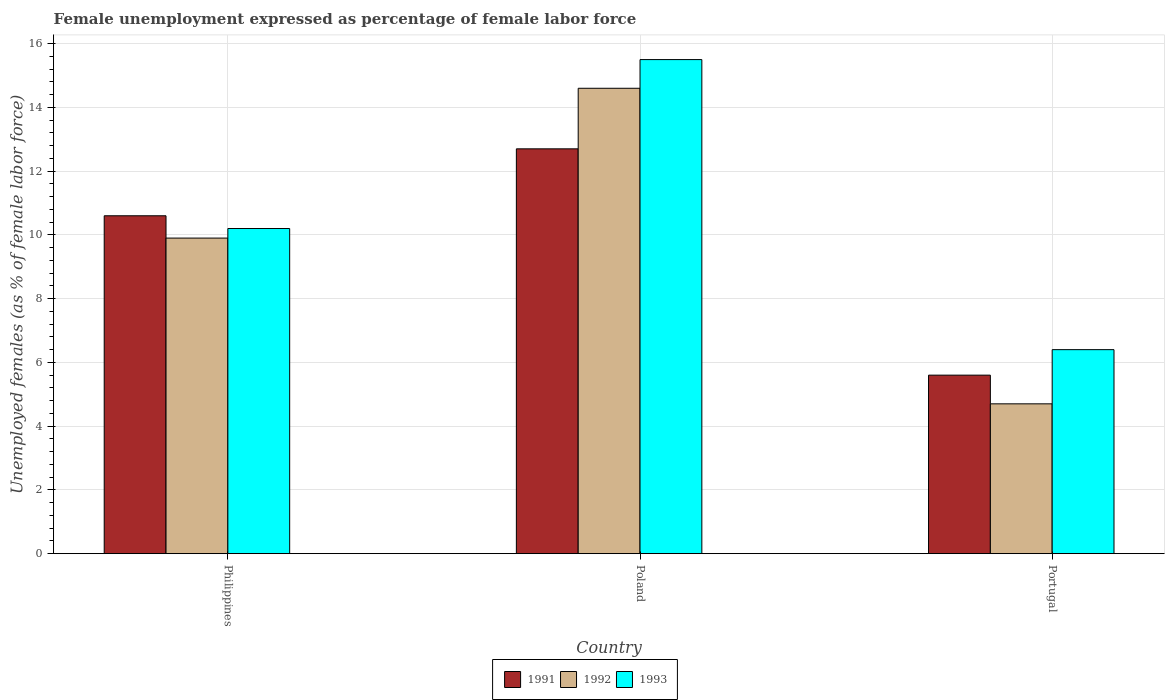How many different coloured bars are there?
Provide a short and direct response. 3. How many groups of bars are there?
Give a very brief answer. 3. What is the label of the 2nd group of bars from the left?
Your response must be concise. Poland. In how many cases, is the number of bars for a given country not equal to the number of legend labels?
Give a very brief answer. 0. What is the unemployment in females in in 1993 in Philippines?
Ensure brevity in your answer.  10.2. Across all countries, what is the maximum unemployment in females in in 1991?
Your response must be concise. 12.7. Across all countries, what is the minimum unemployment in females in in 1992?
Your answer should be compact. 4.7. In which country was the unemployment in females in in 1991 maximum?
Provide a short and direct response. Poland. In which country was the unemployment in females in in 1991 minimum?
Your response must be concise. Portugal. What is the total unemployment in females in in 1993 in the graph?
Offer a very short reply. 32.1. What is the difference between the unemployment in females in in 1993 in Philippines and that in Poland?
Make the answer very short. -5.3. What is the difference between the unemployment in females in in 1992 in Poland and the unemployment in females in in 1991 in Philippines?
Your response must be concise. 4. What is the average unemployment in females in in 1991 per country?
Make the answer very short. 9.63. What is the difference between the unemployment in females in of/in 1992 and unemployment in females in of/in 1991 in Portugal?
Your answer should be very brief. -0.9. What is the ratio of the unemployment in females in in 1991 in Philippines to that in Poland?
Give a very brief answer. 0.83. Is the unemployment in females in in 1992 in Poland less than that in Portugal?
Your response must be concise. No. Is the difference between the unemployment in females in in 1992 in Philippines and Portugal greater than the difference between the unemployment in females in in 1991 in Philippines and Portugal?
Provide a short and direct response. Yes. What is the difference between the highest and the second highest unemployment in females in in 1992?
Your response must be concise. 5.2. What is the difference between the highest and the lowest unemployment in females in in 1993?
Make the answer very short. 9.1. In how many countries, is the unemployment in females in in 1993 greater than the average unemployment in females in in 1993 taken over all countries?
Your answer should be very brief. 1. Is the sum of the unemployment in females in in 1991 in Philippines and Portugal greater than the maximum unemployment in females in in 1993 across all countries?
Ensure brevity in your answer.  Yes. What does the 3rd bar from the right in Philippines represents?
Make the answer very short. 1991. Is it the case that in every country, the sum of the unemployment in females in in 1992 and unemployment in females in in 1993 is greater than the unemployment in females in in 1991?
Your answer should be compact. Yes. Are all the bars in the graph horizontal?
Keep it short and to the point. No. Are the values on the major ticks of Y-axis written in scientific E-notation?
Your answer should be very brief. No. Does the graph contain any zero values?
Your response must be concise. No. Does the graph contain grids?
Your response must be concise. Yes. How are the legend labels stacked?
Your answer should be very brief. Horizontal. What is the title of the graph?
Your answer should be compact. Female unemployment expressed as percentage of female labor force. Does "2013" appear as one of the legend labels in the graph?
Your response must be concise. No. What is the label or title of the X-axis?
Make the answer very short. Country. What is the label or title of the Y-axis?
Your answer should be very brief. Unemployed females (as % of female labor force). What is the Unemployed females (as % of female labor force) of 1991 in Philippines?
Ensure brevity in your answer.  10.6. What is the Unemployed females (as % of female labor force) in 1992 in Philippines?
Provide a short and direct response. 9.9. What is the Unemployed females (as % of female labor force) of 1993 in Philippines?
Provide a short and direct response. 10.2. What is the Unemployed females (as % of female labor force) in 1991 in Poland?
Offer a very short reply. 12.7. What is the Unemployed females (as % of female labor force) in 1992 in Poland?
Give a very brief answer. 14.6. What is the Unemployed females (as % of female labor force) in 1993 in Poland?
Offer a very short reply. 15.5. What is the Unemployed females (as % of female labor force) of 1991 in Portugal?
Offer a very short reply. 5.6. What is the Unemployed females (as % of female labor force) of 1992 in Portugal?
Ensure brevity in your answer.  4.7. What is the Unemployed females (as % of female labor force) in 1993 in Portugal?
Offer a very short reply. 6.4. Across all countries, what is the maximum Unemployed females (as % of female labor force) of 1991?
Your answer should be compact. 12.7. Across all countries, what is the maximum Unemployed females (as % of female labor force) in 1992?
Your response must be concise. 14.6. Across all countries, what is the maximum Unemployed females (as % of female labor force) of 1993?
Provide a short and direct response. 15.5. Across all countries, what is the minimum Unemployed females (as % of female labor force) in 1991?
Give a very brief answer. 5.6. Across all countries, what is the minimum Unemployed females (as % of female labor force) of 1992?
Your answer should be very brief. 4.7. Across all countries, what is the minimum Unemployed females (as % of female labor force) in 1993?
Provide a succinct answer. 6.4. What is the total Unemployed females (as % of female labor force) in 1991 in the graph?
Offer a very short reply. 28.9. What is the total Unemployed females (as % of female labor force) in 1992 in the graph?
Your answer should be very brief. 29.2. What is the total Unemployed females (as % of female labor force) of 1993 in the graph?
Provide a short and direct response. 32.1. What is the difference between the Unemployed females (as % of female labor force) of 1991 in Philippines and that in Poland?
Make the answer very short. -2.1. What is the difference between the Unemployed females (as % of female labor force) of 1991 in Philippines and that in Portugal?
Your answer should be compact. 5. What is the difference between the Unemployed females (as % of female labor force) of 1992 in Philippines and that in Portugal?
Keep it short and to the point. 5.2. What is the difference between the Unemployed females (as % of female labor force) of 1991 in Poland and that in Portugal?
Your answer should be very brief. 7.1. What is the difference between the Unemployed females (as % of female labor force) of 1993 in Poland and that in Portugal?
Keep it short and to the point. 9.1. What is the difference between the Unemployed females (as % of female labor force) in 1991 in Philippines and the Unemployed females (as % of female labor force) in 1992 in Poland?
Offer a terse response. -4. What is the difference between the Unemployed females (as % of female labor force) of 1991 in Philippines and the Unemployed females (as % of female labor force) of 1993 in Poland?
Give a very brief answer. -4.9. What is the difference between the Unemployed females (as % of female labor force) in 1992 in Philippines and the Unemployed females (as % of female labor force) in 1993 in Poland?
Provide a short and direct response. -5.6. What is the difference between the Unemployed females (as % of female labor force) in 1991 in Philippines and the Unemployed females (as % of female labor force) in 1992 in Portugal?
Your answer should be compact. 5.9. What is the difference between the Unemployed females (as % of female labor force) in 1992 in Philippines and the Unemployed females (as % of female labor force) in 1993 in Portugal?
Make the answer very short. 3.5. What is the difference between the Unemployed females (as % of female labor force) of 1991 in Poland and the Unemployed females (as % of female labor force) of 1992 in Portugal?
Give a very brief answer. 8. What is the difference between the Unemployed females (as % of female labor force) in 1991 in Poland and the Unemployed females (as % of female labor force) in 1993 in Portugal?
Provide a short and direct response. 6.3. What is the average Unemployed females (as % of female labor force) in 1991 per country?
Offer a terse response. 9.63. What is the average Unemployed females (as % of female labor force) of 1992 per country?
Give a very brief answer. 9.73. What is the difference between the Unemployed females (as % of female labor force) in 1991 and Unemployed females (as % of female labor force) in 1992 in Philippines?
Your answer should be compact. 0.7. What is the difference between the Unemployed females (as % of female labor force) of 1992 and Unemployed females (as % of female labor force) of 1993 in Philippines?
Ensure brevity in your answer.  -0.3. What is the difference between the Unemployed females (as % of female labor force) of 1991 and Unemployed females (as % of female labor force) of 1993 in Poland?
Give a very brief answer. -2.8. What is the ratio of the Unemployed females (as % of female labor force) of 1991 in Philippines to that in Poland?
Keep it short and to the point. 0.83. What is the ratio of the Unemployed females (as % of female labor force) of 1992 in Philippines to that in Poland?
Your answer should be very brief. 0.68. What is the ratio of the Unemployed females (as % of female labor force) in 1993 in Philippines to that in Poland?
Give a very brief answer. 0.66. What is the ratio of the Unemployed females (as % of female labor force) in 1991 in Philippines to that in Portugal?
Your answer should be very brief. 1.89. What is the ratio of the Unemployed females (as % of female labor force) of 1992 in Philippines to that in Portugal?
Offer a terse response. 2.11. What is the ratio of the Unemployed females (as % of female labor force) in 1993 in Philippines to that in Portugal?
Offer a terse response. 1.59. What is the ratio of the Unemployed females (as % of female labor force) of 1991 in Poland to that in Portugal?
Keep it short and to the point. 2.27. What is the ratio of the Unemployed females (as % of female labor force) of 1992 in Poland to that in Portugal?
Your answer should be very brief. 3.11. What is the ratio of the Unemployed females (as % of female labor force) in 1993 in Poland to that in Portugal?
Your answer should be very brief. 2.42. What is the difference between the highest and the second highest Unemployed females (as % of female labor force) in 1991?
Provide a succinct answer. 2.1. What is the difference between the highest and the lowest Unemployed females (as % of female labor force) of 1991?
Your answer should be compact. 7.1. What is the difference between the highest and the lowest Unemployed females (as % of female labor force) of 1992?
Give a very brief answer. 9.9. What is the difference between the highest and the lowest Unemployed females (as % of female labor force) in 1993?
Give a very brief answer. 9.1. 